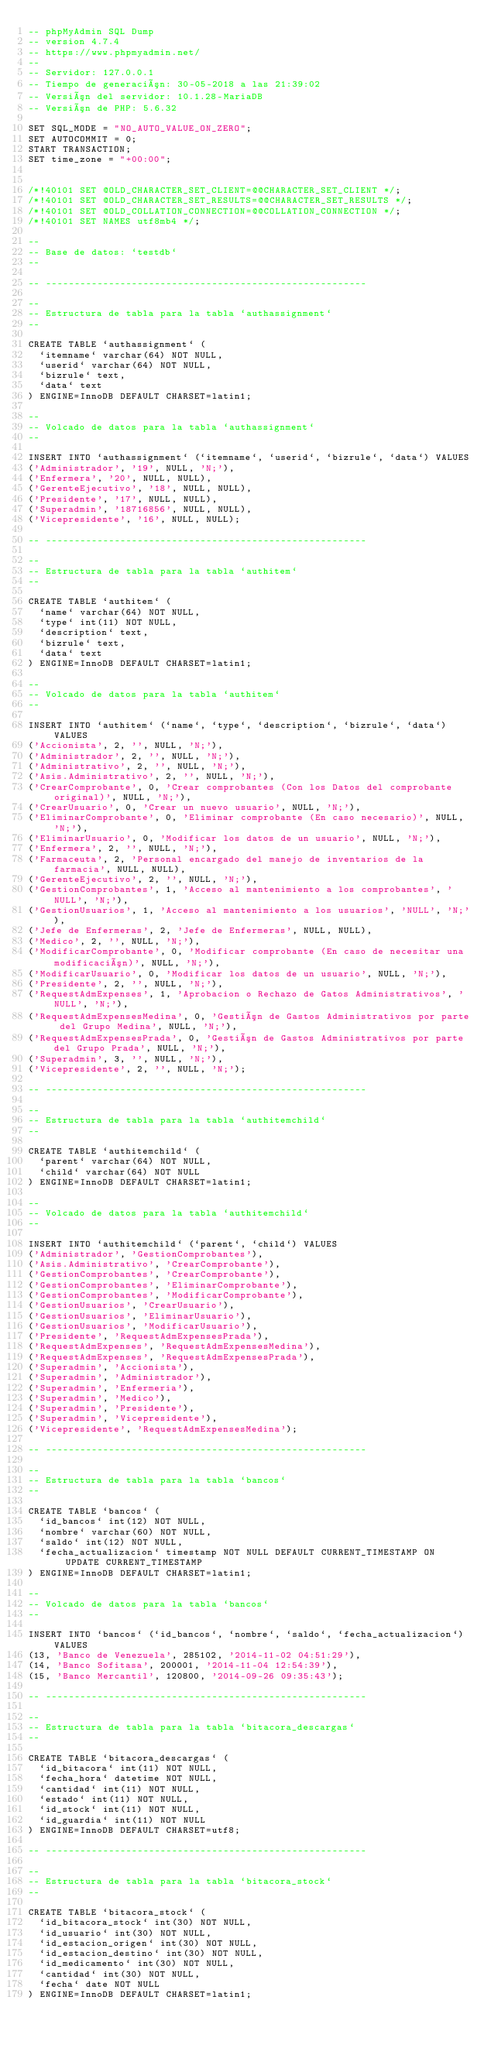Convert code to text. <code><loc_0><loc_0><loc_500><loc_500><_SQL_>-- phpMyAdmin SQL Dump
-- version 4.7.4
-- https://www.phpmyadmin.net/
--
-- Servidor: 127.0.0.1
-- Tiempo de generación: 30-05-2018 a las 21:39:02
-- Versión del servidor: 10.1.28-MariaDB
-- Versión de PHP: 5.6.32

SET SQL_MODE = "NO_AUTO_VALUE_ON_ZERO";
SET AUTOCOMMIT = 0;
START TRANSACTION;
SET time_zone = "+00:00";


/*!40101 SET @OLD_CHARACTER_SET_CLIENT=@@CHARACTER_SET_CLIENT */;
/*!40101 SET @OLD_CHARACTER_SET_RESULTS=@@CHARACTER_SET_RESULTS */;
/*!40101 SET @OLD_COLLATION_CONNECTION=@@COLLATION_CONNECTION */;
/*!40101 SET NAMES utf8mb4 */;

--
-- Base de datos: `testdb`
--

-- --------------------------------------------------------

--
-- Estructura de tabla para la tabla `authassignment`
--

CREATE TABLE `authassignment` (
  `itemname` varchar(64) NOT NULL,
  `userid` varchar(64) NOT NULL,
  `bizrule` text,
  `data` text
) ENGINE=InnoDB DEFAULT CHARSET=latin1;

--
-- Volcado de datos para la tabla `authassignment`
--

INSERT INTO `authassignment` (`itemname`, `userid`, `bizrule`, `data`) VALUES
('Administrador', '19', NULL, 'N;'),
('Enfermera', '20', NULL, NULL),
('GerenteEjecutivo', '18', NULL, NULL),
('Presidente', '17', NULL, NULL),
('Superadmin', '18716856', NULL, NULL),
('Vicepresidente', '16', NULL, NULL);

-- --------------------------------------------------------

--
-- Estructura de tabla para la tabla `authitem`
--

CREATE TABLE `authitem` (
  `name` varchar(64) NOT NULL,
  `type` int(11) NOT NULL,
  `description` text,
  `bizrule` text,
  `data` text
) ENGINE=InnoDB DEFAULT CHARSET=latin1;

--
-- Volcado de datos para la tabla `authitem`
--

INSERT INTO `authitem` (`name`, `type`, `description`, `bizrule`, `data`) VALUES
('Accionista', 2, '', NULL, 'N;'),
('Administrador', 2, '', NULL, 'N;'),
('Administrativo', 2, '', NULL, 'N;'),
('Asis.Administrativo', 2, '', NULL, 'N;'),
('CrearComprobante', 0, 'Crear comprobantes (Con los Datos del comprobante original)', NULL, 'N;'),
('CrearUsuario', 0, 'Crear un nuevo usuario', NULL, 'N;'),
('EliminarComprobante', 0, 'Eliminar comprobante (En caso necesario)', NULL, 'N;'),
('EliminarUsuario', 0, 'Modificar los datos de un usuario', NULL, 'N;'),
('Enfermera', 2, '', NULL, 'N;'),
('Farmaceuta', 2, 'Personal encargado del manejo de inventarios de la farmacia', NULL, NULL),
('GerenteEjecutivo', 2, '', NULL, 'N;'),
('GestionComprobantes', 1, 'Acceso al mantenimiento a los comprobantes', 'NULL', 'N;'),
('GestionUsuarios', 1, 'Acceso al mantenimiento a los usuarios', 'NULL', 'N;'),
('Jefe de Enfermeras', 2, 'Jefe de Enfermeras', NULL, NULL),
('Medico', 2, '', NULL, 'N;'),
('ModificarComprobante', 0, 'Modificar comprobante (En caso de necesitar una modificación)', NULL, 'N;'),
('ModificarUsuario', 0, 'Modificar los datos de un usuario', NULL, 'N;'),
('Presidente', 2, '', NULL, 'N;'),
('RequestAdmExpenses', 1, 'Aprobacion o Rechazo de Gatos Administrativos', 'NULL', 'N;'),
('RequestAdmExpensesMedina', 0, 'Gestión de Gastos Administrativos por parte del Grupo Medina', NULL, 'N;'),
('RequestAdmExpensesPrada', 0, 'Gestión de Gastos Administrativos por parte del Grupo Prada', NULL, 'N;'),
('Superadmin', 3, '', NULL, 'N;'),
('Vicepresidente', 2, '', NULL, 'N;');

-- --------------------------------------------------------

--
-- Estructura de tabla para la tabla `authitemchild`
--

CREATE TABLE `authitemchild` (
  `parent` varchar(64) NOT NULL,
  `child` varchar(64) NOT NULL
) ENGINE=InnoDB DEFAULT CHARSET=latin1;

--
-- Volcado de datos para la tabla `authitemchild`
--

INSERT INTO `authitemchild` (`parent`, `child`) VALUES
('Administrador', 'GestionComprobantes'),
('Asis.Administrativo', 'CrearComprobante'),
('GestionComprobantes', 'CrearComprobante'),
('GestionComprobantes', 'EliminarComprobante'),
('GestionComprobantes', 'ModificarComprobante'),
('GestionUsuarios', 'CrearUsuario'),
('GestionUsuarios', 'EliminarUsuario'),
('GestionUsuarios', 'ModificarUsuario'),
('Presidente', 'RequestAdmExpensesPrada'),
('RequestAdmExpenses', 'RequestAdmExpensesMedina'),
('RequestAdmExpenses', 'RequestAdmExpensesPrada'),
('Superadmin', 'Accionista'),
('Superadmin', 'Administrador'),
('Superadmin', 'Enfermeria'),
('Superadmin', 'Medico'),
('Superadmin', 'Presidente'),
('Superadmin', 'Vicepresidente'),
('Vicepresidente', 'RequestAdmExpensesMedina');

-- --------------------------------------------------------

--
-- Estructura de tabla para la tabla `bancos`
--

CREATE TABLE `bancos` (
  `id_bancos` int(12) NOT NULL,
  `nombre` varchar(60) NOT NULL,
  `saldo` int(12) NOT NULL,
  `fecha_actualizacion` timestamp NOT NULL DEFAULT CURRENT_TIMESTAMP ON UPDATE CURRENT_TIMESTAMP
) ENGINE=InnoDB DEFAULT CHARSET=latin1;

--
-- Volcado de datos para la tabla `bancos`
--

INSERT INTO `bancos` (`id_bancos`, `nombre`, `saldo`, `fecha_actualizacion`) VALUES
(13, 'Banco de Venezuela', 285102, '2014-11-02 04:51:29'),
(14, 'Banco Sofitasa', 200001, '2014-11-04 12:54:39'),
(15, 'Banco Mercantil', 120800, '2014-09-26 09:35:43');

-- --------------------------------------------------------

--
-- Estructura de tabla para la tabla `bitacora_descargas`
--

CREATE TABLE `bitacora_descargas` (
  `id_bitacora` int(11) NOT NULL,
  `fecha_hora` datetime NOT NULL,
  `cantidad` int(11) NOT NULL,
  `estado` int(11) NOT NULL,
  `id_stock` int(11) NOT NULL,
  `id_guardia` int(11) NOT NULL
) ENGINE=InnoDB DEFAULT CHARSET=utf8;

-- --------------------------------------------------------

--
-- Estructura de tabla para la tabla `bitacora_stock`
--

CREATE TABLE `bitacora_stock` (
  `id_bitacora_stock` int(30) NOT NULL,
  `id_usuario` int(30) NOT NULL,
  `id_estacion_origen` int(30) NOT NULL,
  `id_estacion_destino` int(30) NOT NULL,
  `id_medicamento` int(30) NOT NULL,
  `cantidad` int(30) NOT NULL,
  `fecha` date NOT NULL
) ENGINE=InnoDB DEFAULT CHARSET=latin1;
</code> 